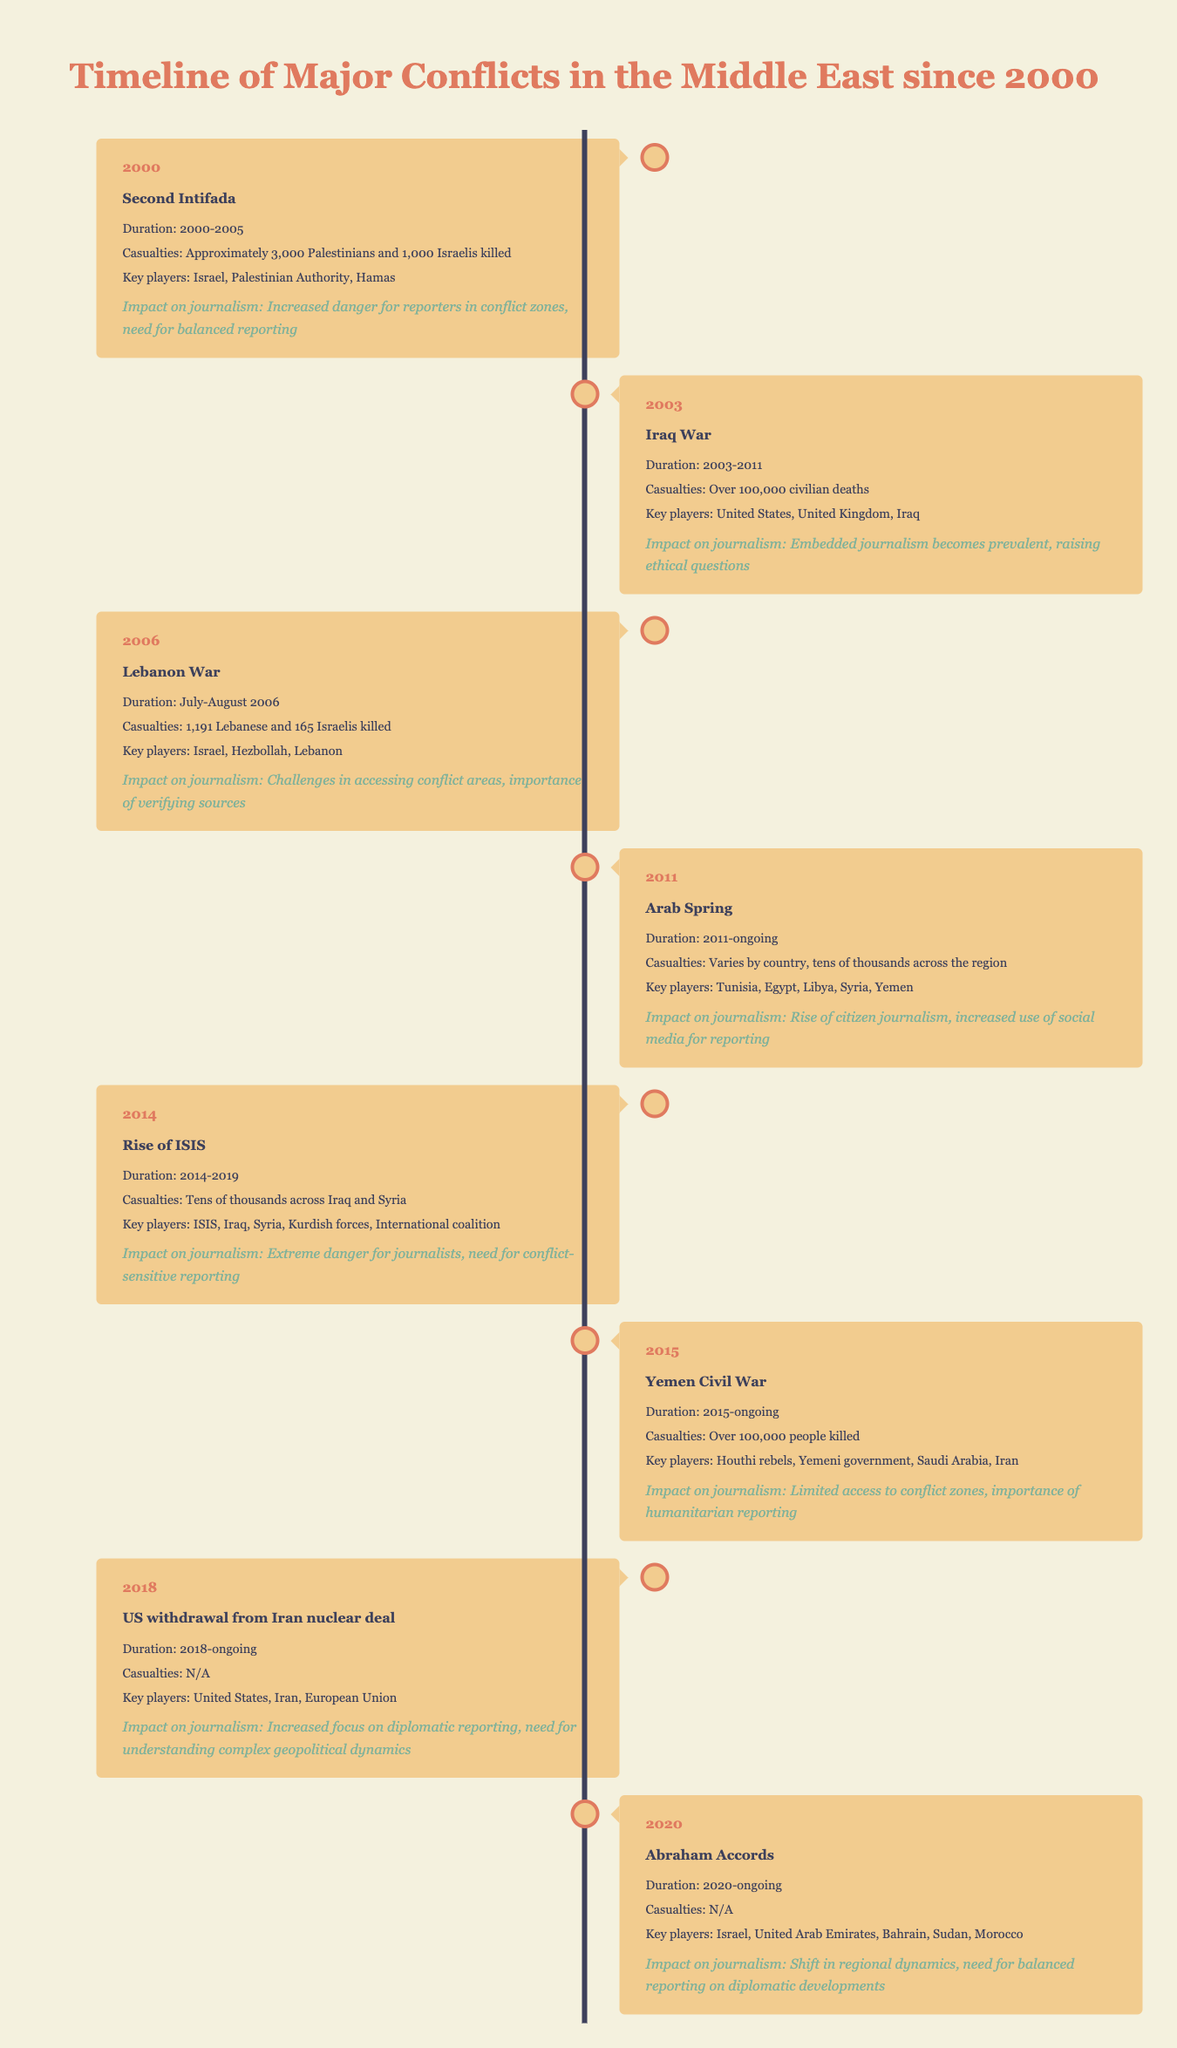What event began in 2000 related to Israel and the Palestinian territories? The table indicates that the "Second Intifada" began in 2000, which is a key event related to Israel and the Palestinian territories.
Answer: Second Intifada How many Lebanese and Israelis were killed during the Lebanon War in 2006? According to the table, during the Lebanon War in 2006, there were 1,191 Lebanese and 165 Israelis killed.
Answer: 1,191 Lebanese and 165 Israelis What is the duration of the Yemen Civil War? The Yemen Civil War started in 2015 and is listed as ongoing in the table, indicating that it has been occurring since that year without a specified end date.
Answer: 2015-ongoing True or False: The Iraq War lasted from 2003 to 2011. The table confirms that the Iraq War is recorded with this duration, making the statement true.
Answer: True What is the total number of casualties from both the Second Intifada and the Iraq War? For the Second Intifada, approximately 3,000 Palestinians and 1,000 Israelis were killed, which totals about 4,000. The Iraq War resulted in over 100,000 civilian deaths. Therefore, the total is approximately 104,000 casualties when combined.
Answer: Approximately 104,000 How has the impact on journalism evolved from the Iraq War to the Rise of ISIS? The Iraq War led to prevalent embedded journalism raising ethical questions, while the Rise of ISIS resulted in extreme dangers for journalists, emphasizing the need for conflict-sensitive reporting. This indicates a shift from ethical considerations to increased danger in reporting.
Answer: It evolved from ethical concerns to extreme danger What are the key players involved in the Arab Spring? The table lists the key players as Tunisia, Egypt, Libya, Syria, and Yemen during the period of the Arab Spring starting in 2011.
Answer: Tunisia, Egypt, Libya, Syria, Yemen How many years did the Second Intifada last? The Second Intifada lasted from 2000 to 2005, which makes it a duration of 5 years.
Answer: 5 years What impact did the US withdrawal from the Iran nuclear deal have on journalism? The table outlines that the withdrawal increased focus on diplomatic reporting and necessitated a better understanding of complex geopolitical dynamics, highlighting a shift in journalistic focus.
Answer: Increased focus on diplomatic reporting and understanding geopolitics 